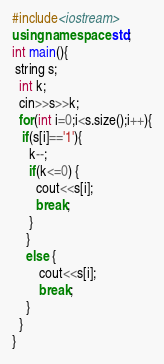<code> <loc_0><loc_0><loc_500><loc_500><_C++_>#include<iostream>
using namespace std;
int main(){
 string s;
  int k;
  cin>>s>>k;
  for(int i=0;i<s.size();i++){
   if(s[i]=='1'){
     k--;
     if(k<=0) {
       cout<<s[i];
       break;
     }
  	}
    else {
    	cout<<s[i];
    	break;
	}
  }
}</code> 